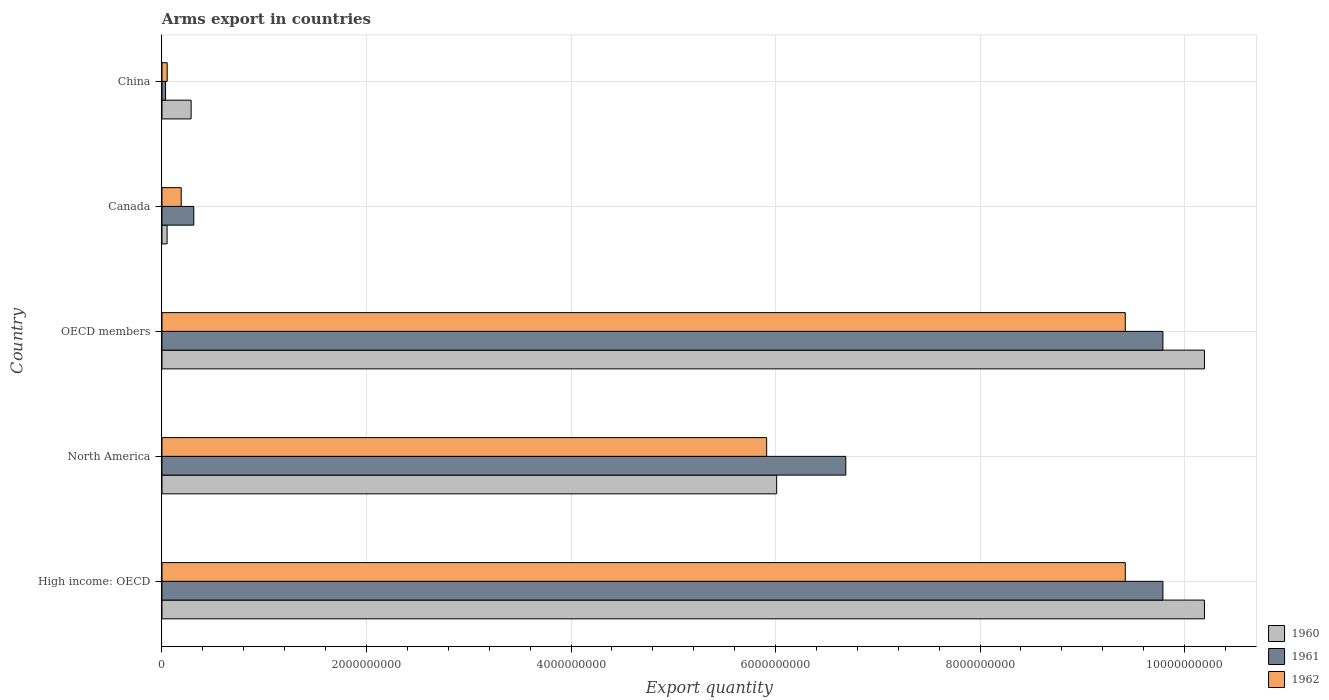How many bars are there on the 4th tick from the top?
Your answer should be compact. 3. What is the label of the 4th group of bars from the top?
Ensure brevity in your answer.  North America. What is the total arms export in 1961 in High income: OECD?
Your answer should be very brief. 9.79e+09. Across all countries, what is the maximum total arms export in 1960?
Your response must be concise. 1.02e+1. Across all countries, what is the minimum total arms export in 1960?
Give a very brief answer. 5.00e+07. In which country was the total arms export in 1960 maximum?
Keep it short and to the point. High income: OECD. What is the total total arms export in 1960 in the graph?
Your answer should be very brief. 2.67e+1. What is the difference between the total arms export in 1961 in China and that in High income: OECD?
Make the answer very short. -9.75e+09. What is the difference between the total arms export in 1961 in North America and the total arms export in 1960 in China?
Your response must be concise. 6.40e+09. What is the average total arms export in 1962 per country?
Keep it short and to the point. 5.00e+09. What is the difference between the total arms export in 1962 and total arms export in 1960 in Canada?
Your answer should be compact. 1.38e+08. What is the ratio of the total arms export in 1962 in China to that in OECD members?
Your response must be concise. 0.01. Is the total arms export in 1961 in Canada less than that in China?
Offer a very short reply. No. Is the difference between the total arms export in 1962 in North America and OECD members greater than the difference between the total arms export in 1960 in North America and OECD members?
Provide a short and direct response. Yes. What is the difference between the highest and the lowest total arms export in 1960?
Make the answer very short. 1.01e+1. In how many countries, is the total arms export in 1961 greater than the average total arms export in 1961 taken over all countries?
Keep it short and to the point. 3. Is it the case that in every country, the sum of the total arms export in 1962 and total arms export in 1960 is greater than the total arms export in 1961?
Give a very brief answer. No. How many bars are there?
Offer a very short reply. 15. Are all the bars in the graph horizontal?
Give a very brief answer. Yes. Are the values on the major ticks of X-axis written in scientific E-notation?
Your answer should be compact. No. Does the graph contain any zero values?
Your answer should be compact. No. Does the graph contain grids?
Offer a very short reply. Yes. Where does the legend appear in the graph?
Your answer should be very brief. Bottom right. How are the legend labels stacked?
Your answer should be very brief. Vertical. What is the title of the graph?
Offer a terse response. Arms export in countries. Does "1997" appear as one of the legend labels in the graph?
Offer a very short reply. No. What is the label or title of the X-axis?
Offer a very short reply. Export quantity. What is the label or title of the Y-axis?
Ensure brevity in your answer.  Country. What is the Export quantity in 1960 in High income: OECD?
Offer a very short reply. 1.02e+1. What is the Export quantity of 1961 in High income: OECD?
Give a very brief answer. 9.79e+09. What is the Export quantity of 1962 in High income: OECD?
Offer a very short reply. 9.42e+09. What is the Export quantity in 1960 in North America?
Make the answer very short. 6.01e+09. What is the Export quantity in 1961 in North America?
Make the answer very short. 6.69e+09. What is the Export quantity of 1962 in North America?
Make the answer very short. 5.91e+09. What is the Export quantity in 1960 in OECD members?
Provide a short and direct response. 1.02e+1. What is the Export quantity of 1961 in OECD members?
Offer a terse response. 9.79e+09. What is the Export quantity of 1962 in OECD members?
Provide a short and direct response. 9.42e+09. What is the Export quantity in 1961 in Canada?
Offer a terse response. 3.11e+08. What is the Export quantity in 1962 in Canada?
Ensure brevity in your answer.  1.88e+08. What is the Export quantity of 1960 in China?
Make the answer very short. 2.85e+08. What is the Export quantity of 1961 in China?
Give a very brief answer. 3.50e+07. What is the Export quantity of 1962 in China?
Provide a succinct answer. 5.10e+07. Across all countries, what is the maximum Export quantity in 1960?
Offer a very short reply. 1.02e+1. Across all countries, what is the maximum Export quantity in 1961?
Make the answer very short. 9.79e+09. Across all countries, what is the maximum Export quantity of 1962?
Offer a very short reply. 9.42e+09. Across all countries, what is the minimum Export quantity of 1960?
Keep it short and to the point. 5.00e+07. Across all countries, what is the minimum Export quantity of 1961?
Provide a short and direct response. 3.50e+07. Across all countries, what is the minimum Export quantity in 1962?
Give a very brief answer. 5.10e+07. What is the total Export quantity in 1960 in the graph?
Provide a succinct answer. 2.67e+1. What is the total Export quantity of 1961 in the graph?
Offer a terse response. 2.66e+1. What is the total Export quantity in 1962 in the graph?
Provide a short and direct response. 2.50e+1. What is the difference between the Export quantity in 1960 in High income: OECD and that in North America?
Your answer should be very brief. 4.18e+09. What is the difference between the Export quantity of 1961 in High income: OECD and that in North America?
Offer a very short reply. 3.10e+09. What is the difference between the Export quantity of 1962 in High income: OECD and that in North America?
Make the answer very short. 3.51e+09. What is the difference between the Export quantity of 1960 in High income: OECD and that in OECD members?
Offer a terse response. 0. What is the difference between the Export quantity of 1961 in High income: OECD and that in OECD members?
Offer a terse response. 0. What is the difference between the Export quantity of 1962 in High income: OECD and that in OECD members?
Provide a succinct answer. 0. What is the difference between the Export quantity in 1960 in High income: OECD and that in Canada?
Your answer should be very brief. 1.01e+1. What is the difference between the Export quantity in 1961 in High income: OECD and that in Canada?
Keep it short and to the point. 9.48e+09. What is the difference between the Export quantity of 1962 in High income: OECD and that in Canada?
Provide a succinct answer. 9.23e+09. What is the difference between the Export quantity of 1960 in High income: OECD and that in China?
Make the answer very short. 9.91e+09. What is the difference between the Export quantity of 1961 in High income: OECD and that in China?
Your answer should be very brief. 9.75e+09. What is the difference between the Export quantity in 1962 in High income: OECD and that in China?
Offer a very short reply. 9.37e+09. What is the difference between the Export quantity of 1960 in North America and that in OECD members?
Keep it short and to the point. -4.18e+09. What is the difference between the Export quantity of 1961 in North America and that in OECD members?
Your answer should be very brief. -3.10e+09. What is the difference between the Export quantity in 1962 in North America and that in OECD members?
Ensure brevity in your answer.  -3.51e+09. What is the difference between the Export quantity in 1960 in North America and that in Canada?
Offer a terse response. 5.96e+09. What is the difference between the Export quantity in 1961 in North America and that in Canada?
Your answer should be compact. 6.38e+09. What is the difference between the Export quantity of 1962 in North America and that in Canada?
Ensure brevity in your answer.  5.72e+09. What is the difference between the Export quantity of 1960 in North America and that in China?
Your response must be concise. 5.73e+09. What is the difference between the Export quantity of 1961 in North America and that in China?
Keep it short and to the point. 6.65e+09. What is the difference between the Export quantity of 1962 in North America and that in China?
Provide a short and direct response. 5.86e+09. What is the difference between the Export quantity of 1960 in OECD members and that in Canada?
Keep it short and to the point. 1.01e+1. What is the difference between the Export quantity in 1961 in OECD members and that in Canada?
Make the answer very short. 9.48e+09. What is the difference between the Export quantity in 1962 in OECD members and that in Canada?
Your answer should be compact. 9.23e+09. What is the difference between the Export quantity in 1960 in OECD members and that in China?
Make the answer very short. 9.91e+09. What is the difference between the Export quantity in 1961 in OECD members and that in China?
Ensure brevity in your answer.  9.75e+09. What is the difference between the Export quantity of 1962 in OECD members and that in China?
Your answer should be compact. 9.37e+09. What is the difference between the Export quantity of 1960 in Canada and that in China?
Give a very brief answer. -2.35e+08. What is the difference between the Export quantity in 1961 in Canada and that in China?
Give a very brief answer. 2.76e+08. What is the difference between the Export quantity in 1962 in Canada and that in China?
Ensure brevity in your answer.  1.37e+08. What is the difference between the Export quantity of 1960 in High income: OECD and the Export quantity of 1961 in North America?
Give a very brief answer. 3.51e+09. What is the difference between the Export quantity of 1960 in High income: OECD and the Export quantity of 1962 in North America?
Provide a succinct answer. 4.28e+09. What is the difference between the Export quantity in 1961 in High income: OECD and the Export quantity in 1962 in North America?
Keep it short and to the point. 3.88e+09. What is the difference between the Export quantity of 1960 in High income: OECD and the Export quantity of 1961 in OECD members?
Ensure brevity in your answer.  4.06e+08. What is the difference between the Export quantity of 1960 in High income: OECD and the Export quantity of 1962 in OECD members?
Your answer should be very brief. 7.74e+08. What is the difference between the Export quantity of 1961 in High income: OECD and the Export quantity of 1962 in OECD members?
Your response must be concise. 3.68e+08. What is the difference between the Export quantity in 1960 in High income: OECD and the Export quantity in 1961 in Canada?
Offer a very short reply. 9.88e+09. What is the difference between the Export quantity in 1960 in High income: OECD and the Export quantity in 1962 in Canada?
Keep it short and to the point. 1.00e+1. What is the difference between the Export quantity in 1961 in High income: OECD and the Export quantity in 1962 in Canada?
Your answer should be compact. 9.60e+09. What is the difference between the Export quantity of 1960 in High income: OECD and the Export quantity of 1961 in China?
Your answer should be compact. 1.02e+1. What is the difference between the Export quantity of 1960 in High income: OECD and the Export quantity of 1962 in China?
Offer a very short reply. 1.01e+1. What is the difference between the Export quantity of 1961 in High income: OECD and the Export quantity of 1962 in China?
Your response must be concise. 9.74e+09. What is the difference between the Export quantity in 1960 in North America and the Export quantity in 1961 in OECD members?
Provide a short and direct response. -3.78e+09. What is the difference between the Export quantity in 1960 in North America and the Export quantity in 1962 in OECD members?
Make the answer very short. -3.41e+09. What is the difference between the Export quantity in 1961 in North America and the Export quantity in 1962 in OECD members?
Offer a very short reply. -2.73e+09. What is the difference between the Export quantity of 1960 in North America and the Export quantity of 1961 in Canada?
Your response must be concise. 5.70e+09. What is the difference between the Export quantity in 1960 in North America and the Export quantity in 1962 in Canada?
Ensure brevity in your answer.  5.82e+09. What is the difference between the Export quantity of 1961 in North America and the Export quantity of 1962 in Canada?
Offer a very short reply. 6.50e+09. What is the difference between the Export quantity in 1960 in North America and the Export quantity in 1961 in China?
Offer a terse response. 5.98e+09. What is the difference between the Export quantity of 1960 in North America and the Export quantity of 1962 in China?
Your answer should be very brief. 5.96e+09. What is the difference between the Export quantity in 1961 in North America and the Export quantity in 1962 in China?
Your response must be concise. 6.64e+09. What is the difference between the Export quantity of 1960 in OECD members and the Export quantity of 1961 in Canada?
Your response must be concise. 9.88e+09. What is the difference between the Export quantity of 1960 in OECD members and the Export quantity of 1962 in Canada?
Offer a very short reply. 1.00e+1. What is the difference between the Export quantity of 1961 in OECD members and the Export quantity of 1962 in Canada?
Give a very brief answer. 9.60e+09. What is the difference between the Export quantity of 1960 in OECD members and the Export quantity of 1961 in China?
Make the answer very short. 1.02e+1. What is the difference between the Export quantity of 1960 in OECD members and the Export quantity of 1962 in China?
Make the answer very short. 1.01e+1. What is the difference between the Export quantity of 1961 in OECD members and the Export quantity of 1962 in China?
Offer a very short reply. 9.74e+09. What is the difference between the Export quantity of 1960 in Canada and the Export quantity of 1961 in China?
Your answer should be very brief. 1.50e+07. What is the difference between the Export quantity of 1960 in Canada and the Export quantity of 1962 in China?
Provide a succinct answer. -1.00e+06. What is the difference between the Export quantity in 1961 in Canada and the Export quantity in 1962 in China?
Your answer should be very brief. 2.60e+08. What is the average Export quantity in 1960 per country?
Ensure brevity in your answer.  5.35e+09. What is the average Export quantity in 1961 per country?
Provide a short and direct response. 5.32e+09. What is the average Export quantity in 1962 per country?
Offer a terse response. 5.00e+09. What is the difference between the Export quantity in 1960 and Export quantity in 1961 in High income: OECD?
Make the answer very short. 4.06e+08. What is the difference between the Export quantity of 1960 and Export quantity of 1962 in High income: OECD?
Ensure brevity in your answer.  7.74e+08. What is the difference between the Export quantity of 1961 and Export quantity of 1962 in High income: OECD?
Provide a succinct answer. 3.68e+08. What is the difference between the Export quantity in 1960 and Export quantity in 1961 in North America?
Give a very brief answer. -6.76e+08. What is the difference between the Export quantity in 1960 and Export quantity in 1962 in North America?
Offer a very short reply. 9.80e+07. What is the difference between the Export quantity of 1961 and Export quantity of 1962 in North America?
Provide a short and direct response. 7.74e+08. What is the difference between the Export quantity in 1960 and Export quantity in 1961 in OECD members?
Your answer should be compact. 4.06e+08. What is the difference between the Export quantity of 1960 and Export quantity of 1962 in OECD members?
Offer a very short reply. 7.74e+08. What is the difference between the Export quantity in 1961 and Export quantity in 1962 in OECD members?
Keep it short and to the point. 3.68e+08. What is the difference between the Export quantity of 1960 and Export quantity of 1961 in Canada?
Offer a very short reply. -2.61e+08. What is the difference between the Export quantity of 1960 and Export quantity of 1962 in Canada?
Make the answer very short. -1.38e+08. What is the difference between the Export quantity of 1961 and Export quantity of 1962 in Canada?
Offer a terse response. 1.23e+08. What is the difference between the Export quantity in 1960 and Export quantity in 1961 in China?
Offer a terse response. 2.50e+08. What is the difference between the Export quantity of 1960 and Export quantity of 1962 in China?
Ensure brevity in your answer.  2.34e+08. What is the difference between the Export quantity in 1961 and Export quantity in 1962 in China?
Your answer should be very brief. -1.60e+07. What is the ratio of the Export quantity in 1960 in High income: OECD to that in North America?
Give a very brief answer. 1.7. What is the ratio of the Export quantity of 1961 in High income: OECD to that in North America?
Your answer should be compact. 1.46. What is the ratio of the Export quantity of 1962 in High income: OECD to that in North America?
Offer a terse response. 1.59. What is the ratio of the Export quantity of 1961 in High income: OECD to that in OECD members?
Your answer should be very brief. 1. What is the ratio of the Export quantity of 1962 in High income: OECD to that in OECD members?
Your response must be concise. 1. What is the ratio of the Export quantity in 1960 in High income: OECD to that in Canada?
Your answer should be compact. 203.88. What is the ratio of the Export quantity in 1961 in High income: OECD to that in Canada?
Offer a terse response. 31.47. What is the ratio of the Export quantity of 1962 in High income: OECD to that in Canada?
Ensure brevity in your answer.  50.11. What is the ratio of the Export quantity of 1960 in High income: OECD to that in China?
Ensure brevity in your answer.  35.77. What is the ratio of the Export quantity of 1961 in High income: OECD to that in China?
Your answer should be compact. 279.66. What is the ratio of the Export quantity of 1962 in High income: OECD to that in China?
Provide a succinct answer. 184.71. What is the ratio of the Export quantity in 1960 in North America to that in OECD members?
Ensure brevity in your answer.  0.59. What is the ratio of the Export quantity in 1961 in North America to that in OECD members?
Make the answer very short. 0.68. What is the ratio of the Export quantity in 1962 in North America to that in OECD members?
Your answer should be compact. 0.63. What is the ratio of the Export quantity in 1960 in North America to that in Canada?
Provide a succinct answer. 120.22. What is the ratio of the Export quantity in 1961 in North America to that in Canada?
Provide a short and direct response. 21.5. What is the ratio of the Export quantity in 1962 in North America to that in Canada?
Offer a terse response. 31.45. What is the ratio of the Export quantity in 1960 in North America to that in China?
Your response must be concise. 21.09. What is the ratio of the Export quantity in 1961 in North America to that in China?
Make the answer very short. 191.06. What is the ratio of the Export quantity in 1962 in North America to that in China?
Your response must be concise. 115.94. What is the ratio of the Export quantity of 1960 in OECD members to that in Canada?
Your answer should be very brief. 203.88. What is the ratio of the Export quantity in 1961 in OECD members to that in Canada?
Your answer should be compact. 31.47. What is the ratio of the Export quantity of 1962 in OECD members to that in Canada?
Offer a very short reply. 50.11. What is the ratio of the Export quantity of 1960 in OECD members to that in China?
Offer a very short reply. 35.77. What is the ratio of the Export quantity in 1961 in OECD members to that in China?
Provide a succinct answer. 279.66. What is the ratio of the Export quantity of 1962 in OECD members to that in China?
Your response must be concise. 184.71. What is the ratio of the Export quantity in 1960 in Canada to that in China?
Provide a short and direct response. 0.18. What is the ratio of the Export quantity in 1961 in Canada to that in China?
Your response must be concise. 8.89. What is the ratio of the Export quantity in 1962 in Canada to that in China?
Keep it short and to the point. 3.69. What is the difference between the highest and the second highest Export quantity of 1960?
Offer a very short reply. 0. What is the difference between the highest and the second highest Export quantity of 1962?
Your response must be concise. 0. What is the difference between the highest and the lowest Export quantity of 1960?
Keep it short and to the point. 1.01e+1. What is the difference between the highest and the lowest Export quantity in 1961?
Give a very brief answer. 9.75e+09. What is the difference between the highest and the lowest Export quantity of 1962?
Provide a short and direct response. 9.37e+09. 